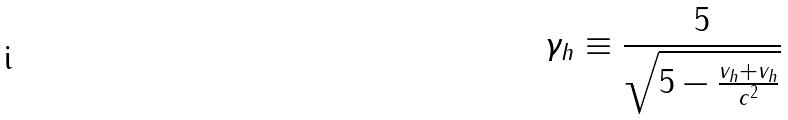Convert formula to latex. <formula><loc_0><loc_0><loc_500><loc_500>\gamma _ { h } \equiv \frac { 5 } { \sqrt { 5 - \frac { v _ { h } + v _ { h } } { c ^ { 2 } } } }</formula> 